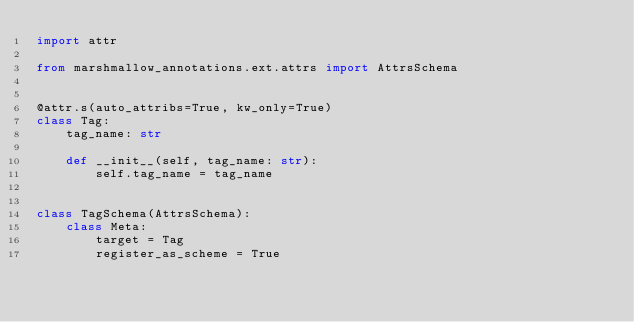<code> <loc_0><loc_0><loc_500><loc_500><_Python_>import attr

from marshmallow_annotations.ext.attrs import AttrsSchema


@attr.s(auto_attribs=True, kw_only=True)
class Tag:
    tag_name: str

    def __init__(self, tag_name: str):
        self.tag_name = tag_name


class TagSchema(AttrsSchema):
    class Meta:
        target = Tag
        register_as_scheme = True
</code> 